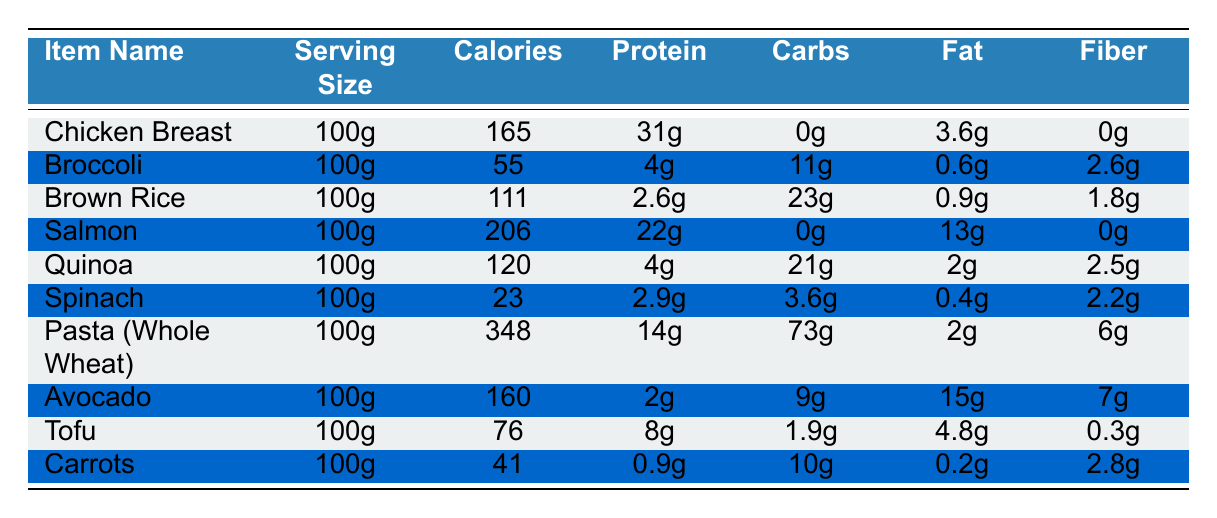What item has the highest calories? By examining the "Calories" column, the highest value is 348, which corresponds to "Pasta (Whole Wheat)."
Answer: Pasta (Whole Wheat) How much protein is in Salmon? Looking at the "Protein" column for "Salmon," it shows 22g of protein for a 100g serving.
Answer: 22g What is the total fat content of Chicken Breast and Salmon combined? The fat content for Chicken Breast is 3.6g and for Salmon is 13g. Adding these together gives 3.6 + 13 = 16.6g.
Answer: 16.6g Is Quinoa lower in calories than Chicken Breast? Quinoa has 120 calories, while Chicken Breast has 165 calories. Since 120 is less than 165, the statement is true.
Answer: Yes Which item has the most fiber? Reviewing the "Fiber" column, "Pasta (Whole Wheat)" has 6g, and "Avocado" has 7g. Therefore, Avocado has the most fiber.
Answer: Avocado What is the average calorie content of Broccoli, Carrots, and Spinach? The calories are 55 (Broccoli), 41 (Carrots), and 23 (Spinach). Their sum is 55 + 41 + 23 = 119. Dividing by 3 gives 119/3 = 39.67, which rounds to 40.
Answer: 40 Is Tofu a higher source of protein than Brown Rice? Tofu has 8g of protein and Brown Rice has 2.6g. Since 8 is greater than 2.6, the statement is true.
Answer: Yes What is the difference in carbohydrates between Avocado and Quinoa? Avocado has 9g of carbohydrates and Quinoa has 21g. The difference is 21 - 9 = 12g.
Answer: 12g How many dinner items listed are classified as low-calorie (under 100 calories)? The items with under 100 calories are Broccoli (55), Brown Rice (111), Spinach (23), and Carrots (41). Therefore, there are 3 qualifying items.
Answer: 3 